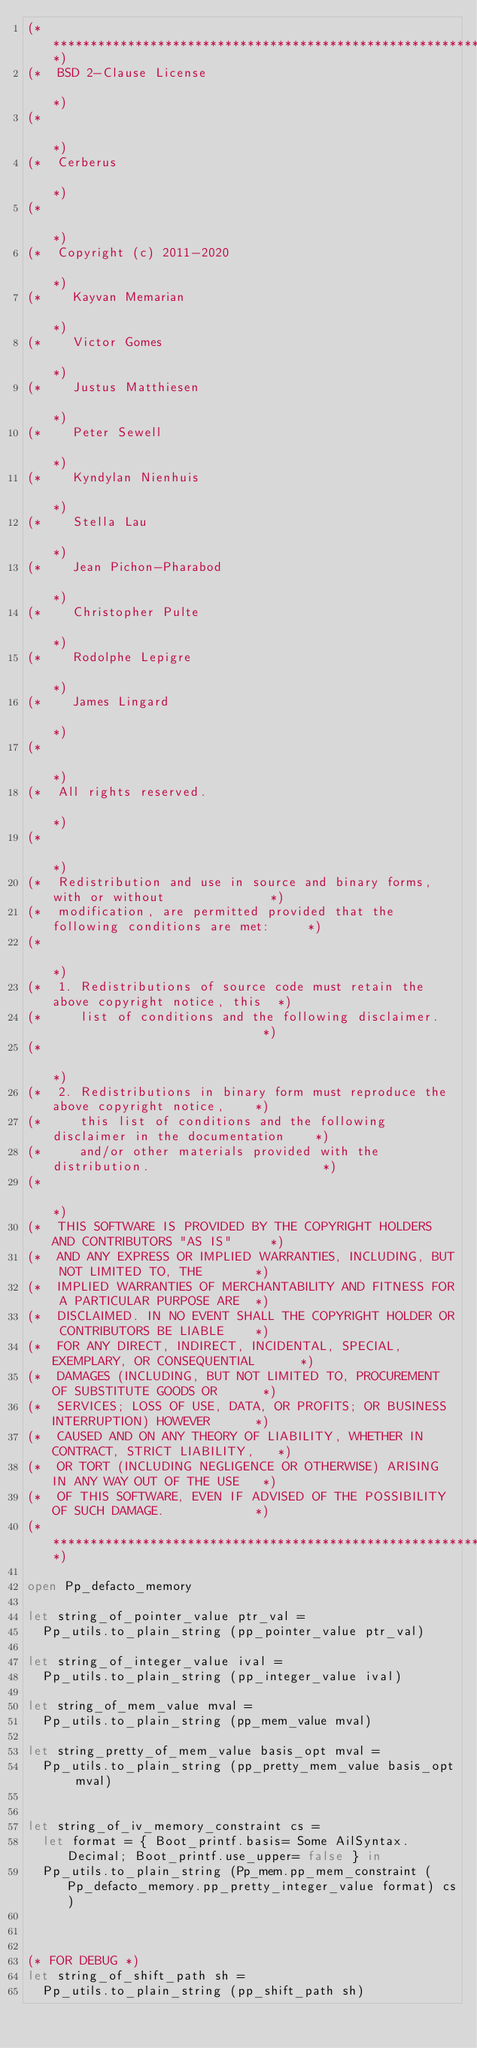<code> <loc_0><loc_0><loc_500><loc_500><_OCaml_>(************************************************************************************)
(*  BSD 2-Clause License                                                            *)
(*                                                                                  *)
(*  Cerberus                                                                        *)
(*                                                                                  *)
(*  Copyright (c) 2011-2020                                                         *)
(*    Kayvan Memarian                                                               *)
(*    Victor Gomes                                                                  *)
(*    Justus Matthiesen                                                             *)
(*    Peter Sewell                                                                  *)
(*    Kyndylan Nienhuis                                                             *)
(*    Stella Lau                                                                    *)
(*    Jean Pichon-Pharabod                                                          *)
(*    Christopher Pulte                                                             *)
(*    Rodolphe Lepigre                                                              *)
(*    James Lingard                                                                 *)
(*                                                                                  *)
(*  All rights reserved.                                                            *)
(*                                                                                  *)
(*  Redistribution and use in source and binary forms, with or without              *)
(*  modification, are permitted provided that the following conditions are met:     *)
(*                                                                                  *)
(*  1. Redistributions of source code must retain the above copyright notice, this  *)
(*     list of conditions and the following disclaimer.                             *)
(*                                                                                  *)
(*  2. Redistributions in binary form must reproduce the above copyright notice,    *)
(*     this list of conditions and the following disclaimer in the documentation    *)
(*     and/or other materials provided with the distribution.                       *)
(*                                                                                  *)
(*  THIS SOFTWARE IS PROVIDED BY THE COPYRIGHT HOLDERS AND CONTRIBUTORS "AS IS"     *)
(*  AND ANY EXPRESS OR IMPLIED WARRANTIES, INCLUDING, BUT NOT LIMITED TO, THE       *)
(*  IMPLIED WARRANTIES OF MERCHANTABILITY AND FITNESS FOR A PARTICULAR PURPOSE ARE  *)
(*  DISCLAIMED. IN NO EVENT SHALL THE COPYRIGHT HOLDER OR CONTRIBUTORS BE LIABLE    *)
(*  FOR ANY DIRECT, INDIRECT, INCIDENTAL, SPECIAL, EXEMPLARY, OR CONSEQUENTIAL      *)
(*  DAMAGES (INCLUDING, BUT NOT LIMITED TO, PROCUREMENT OF SUBSTITUTE GOODS OR      *)
(*  SERVICES; LOSS OF USE, DATA, OR PROFITS; OR BUSINESS INTERRUPTION) HOWEVER      *)
(*  CAUSED AND ON ANY THEORY OF LIABILITY, WHETHER IN CONTRACT, STRICT LIABILITY,   *)
(*  OR TORT (INCLUDING NEGLIGENCE OR OTHERWISE) ARISING IN ANY WAY OUT OF THE USE   *)
(*  OF THIS SOFTWARE, EVEN IF ADVISED OF THE POSSIBILITY OF SUCH DAMAGE.            *)
(************************************************************************************)

open Pp_defacto_memory

let string_of_pointer_value ptr_val =
  Pp_utils.to_plain_string (pp_pointer_value ptr_val)

let string_of_integer_value ival =
  Pp_utils.to_plain_string (pp_integer_value ival)

let string_of_mem_value mval =
  Pp_utils.to_plain_string (pp_mem_value mval)

let string_pretty_of_mem_value basis_opt mval =
  Pp_utils.to_plain_string (pp_pretty_mem_value basis_opt mval)


let string_of_iv_memory_constraint cs =
  let format = { Boot_printf.basis= Some AilSyntax.Decimal; Boot_printf.use_upper= false } in
  Pp_utils.to_plain_string (Pp_mem.pp_mem_constraint (Pp_defacto_memory.pp_pretty_integer_value format) cs)



(* FOR DEBUG *)
let string_of_shift_path sh =
  Pp_utils.to_plain_string (pp_shift_path sh)
</code> 